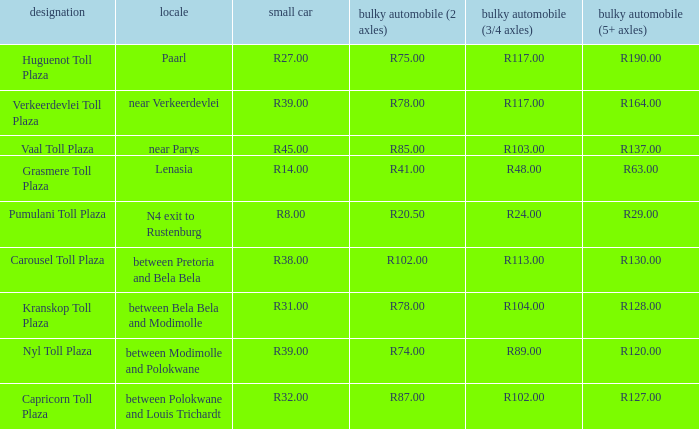What is the name of the plaza where the toll for heavy vehicles with 2 axles is r87.00? Capricorn Toll Plaza. 